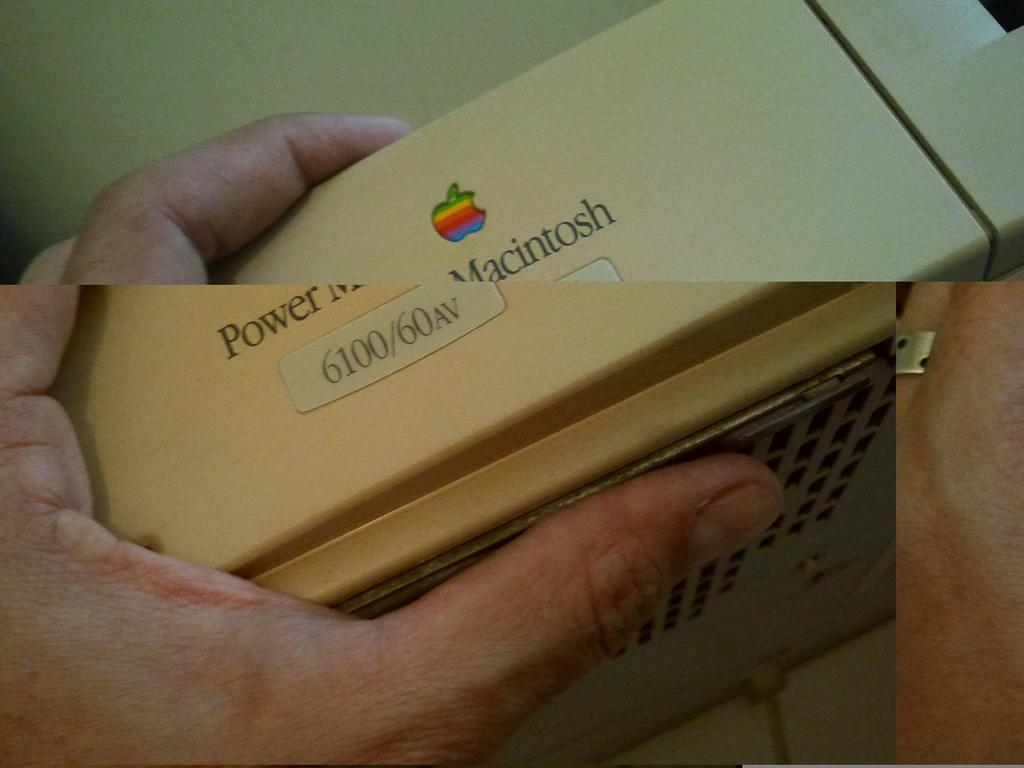<image>
Write a terse but informative summary of the picture. Power Macintosh 6100/60av reads the front of this computer part. 